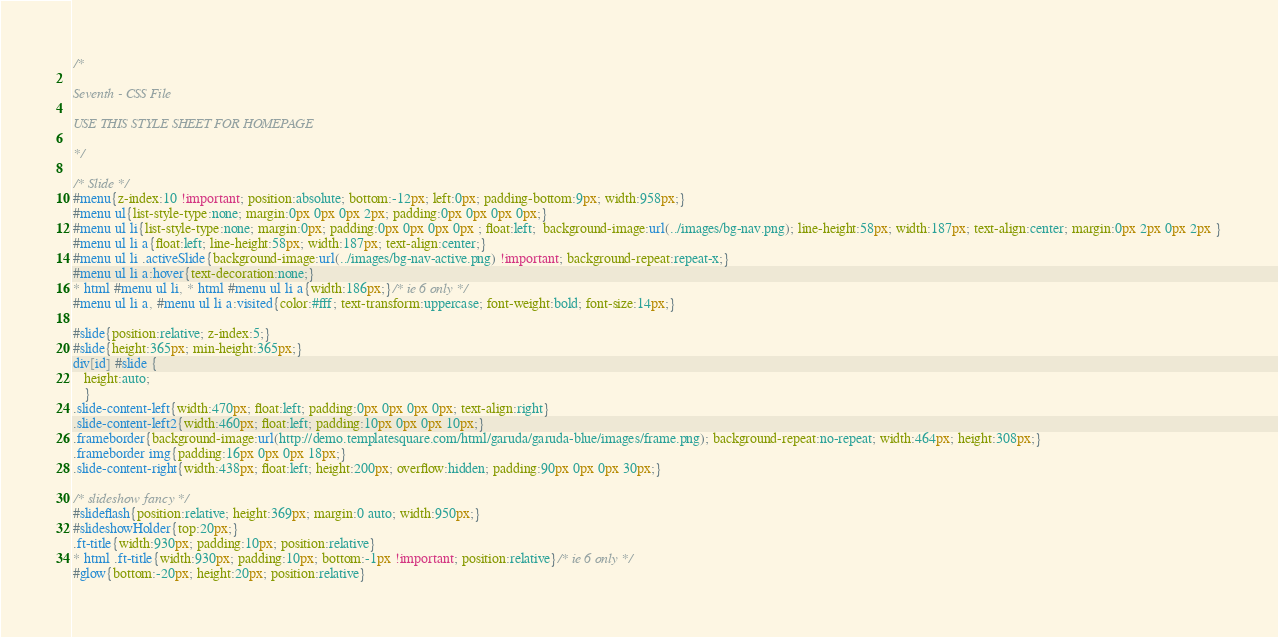Convert code to text. <code><loc_0><loc_0><loc_500><loc_500><_CSS_>/* 

Seventh - CSS File

USE THIS STYLE SHEET FOR HOMEPAGE

*/

/* Slide */
#menu{z-index:10 !important; position:absolute; bottom:-12px; left:0px; padding-bottom:9px; width:958px;}
#menu ul{list-style-type:none; margin:0px 0px 0px 2px; padding:0px 0px 0px 0px;}
#menu ul li{list-style-type:none; margin:0px; padding:0px 0px 0px 0px ; float:left;  background-image:url(../images/bg-nav.png); line-height:58px; width:187px; text-align:center; margin:0px 2px 0px 2px }
#menu ul li a{float:left; line-height:58px; width:187px; text-align:center;}
#menu ul li .activeSlide{background-image:url(../images/bg-nav-active.png) !important; background-repeat:repeat-x;}
#menu ul li a:hover{text-decoration:none;}
* html #menu ul li, * html #menu ul li a{width:186px;}/* ie 6 only */
#menu ul li a, #menu ul li a:visited{color:#fff; text-transform:uppercase; font-weight:bold; font-size:14px;}

#slide{position:relative; z-index:5;}
#slide{height:365px; min-height:365px;}
div[id] #slide {
   height:auto;
   }
.slide-content-left{width:470px; float:left; padding:0px 0px 0px 0px; text-align:right}
.slide-content-left2{width:460px; float:left; padding:10px 0px 0px 10px;}
.frameborder{background-image:url(http://demo.templatesquare.com/html/garuda/garuda-blue/images/frame.png); background-repeat:no-repeat; width:464px; height:308px;}
.frameborder img{padding:16px 0px 0px 18px;}
.slide-content-right{width:438px; float:left; height:200px; overflow:hidden; padding:90px 0px 0px 30px;}

/* slideshow fancy */
#slideflash{position:relative; height:369px; margin:0 auto; width:950px;}
#slideshowHolder{top:20px;}
.ft-title{width:930px; padding:10px; position:relative}
* html .ft-title{width:930px; padding:10px; bottom:-1px !important; position:relative}/* ie 6 only */
#glow{bottom:-20px; height:20px; position:relative}</code> 